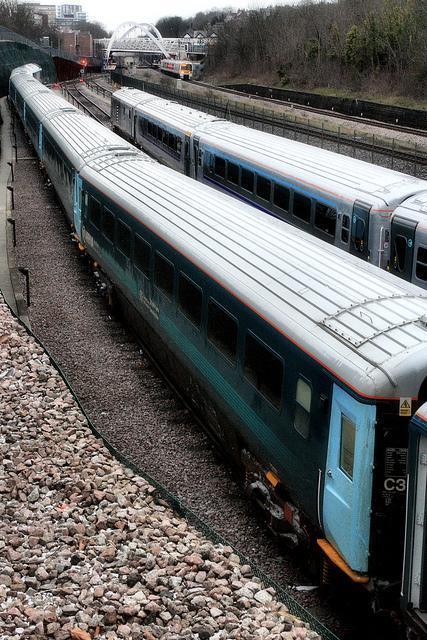How many trains are in the picture?
Give a very brief answer. 2. How many kites are there in the sky?
Give a very brief answer. 0. 